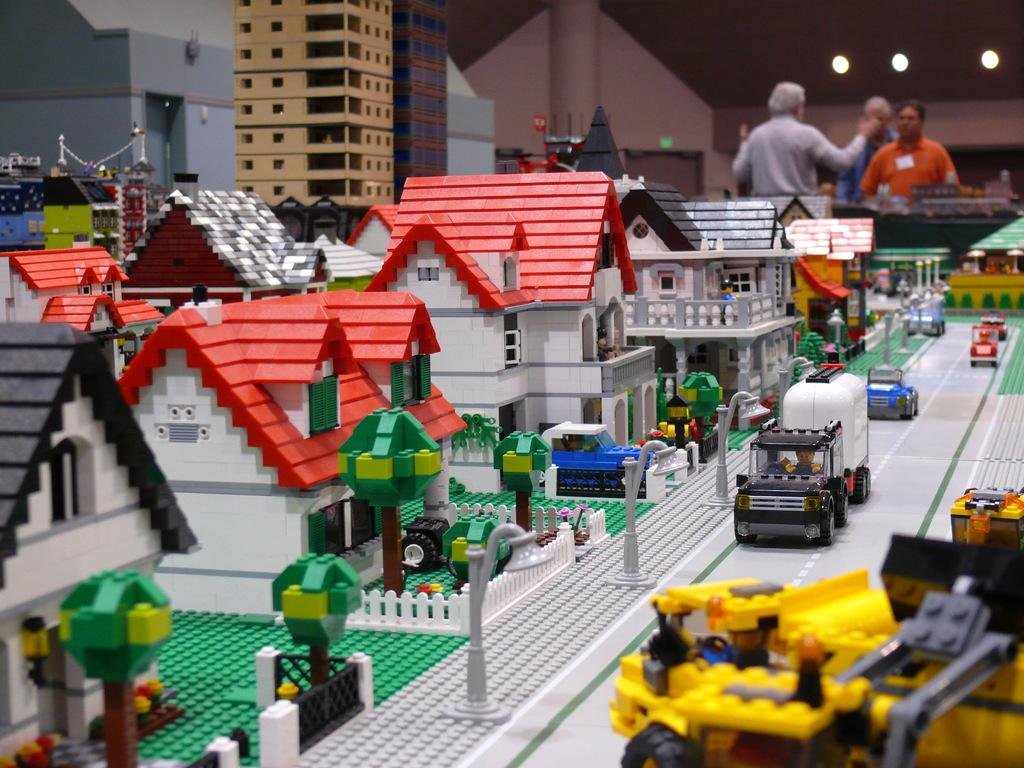What is the main subject of the image? The main subject of the image is a miniature. Can you describe the miniature? The miniature is colorful and includes buildings, windows, trees, fencing, vehicles, and people. How many people are visible in the miniature? There are three people visible in the background. What other elements can be seen in the background? There are lights and a wall visible in the background. What is the chance of winning a prize in the image? There is no indication of a prize or a chance to win in the image; it features a miniature with various elements. How many trees are visible in the image? The image does not specify the number of trees; it only mentions that there are trees in the miniature. How many cars are visible in the image? The image does not specify the number of cars; it only mentions that there are vehicles in the miniature. 